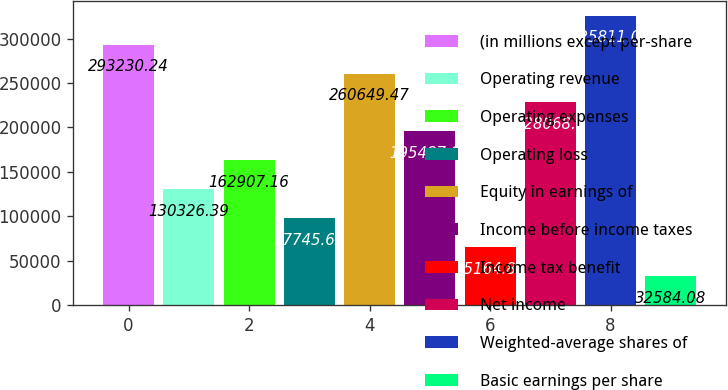Convert chart. <chart><loc_0><loc_0><loc_500><loc_500><bar_chart><fcel>(in millions except per-share<fcel>Operating revenue<fcel>Operating expenses<fcel>Operating loss<fcel>Equity in earnings of<fcel>Income before income taxes<fcel>Income tax benefit<fcel>Net income<fcel>Weighted-average shares of<fcel>Basic earnings per share<nl><fcel>293230<fcel>130326<fcel>162907<fcel>97745.6<fcel>260649<fcel>195488<fcel>65164.8<fcel>228069<fcel>325811<fcel>32584.1<nl></chart> 